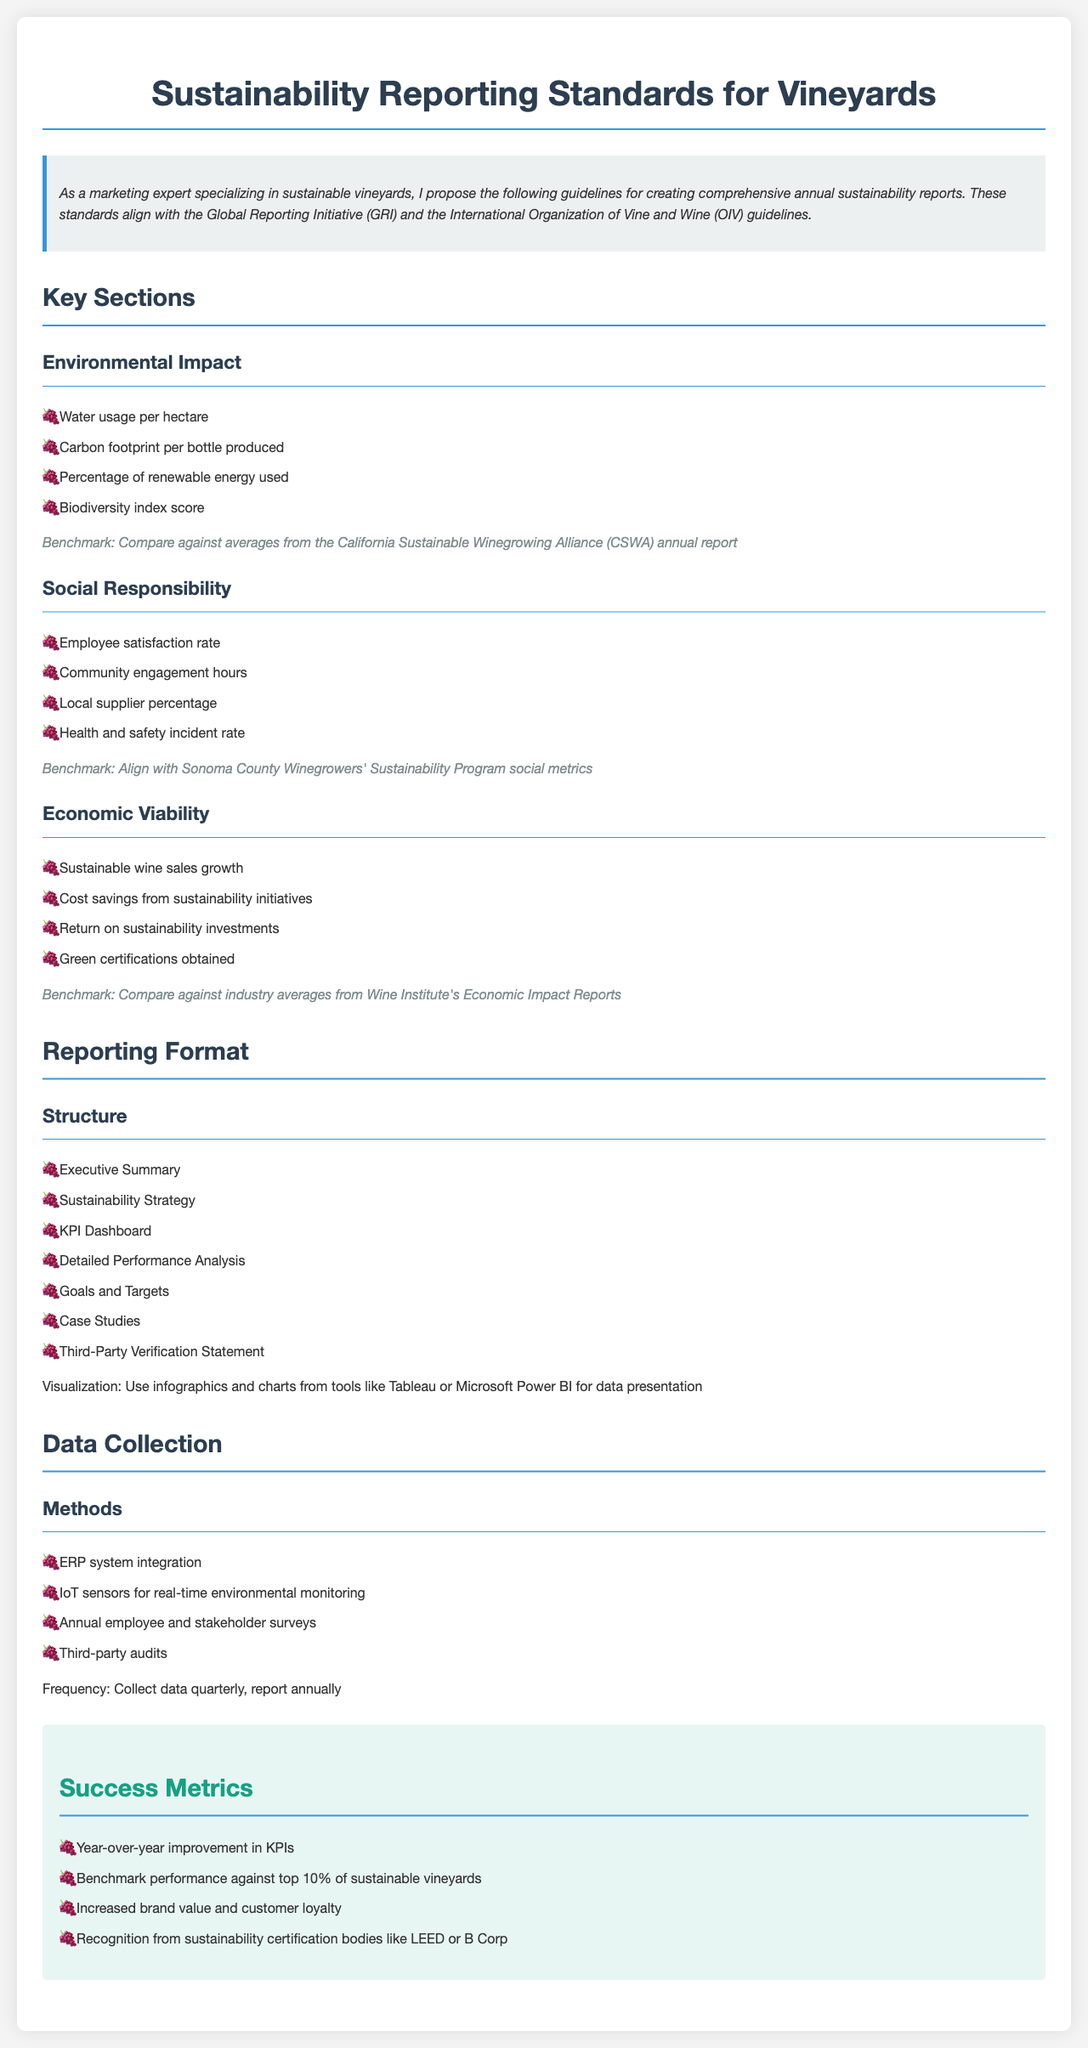What are the key sections in the report? The key sections include Environmental Impact, Social Responsibility, and Economic Viability.
Answer: Environmental Impact, Social Responsibility, Economic Viability What is a benchmark for Environmental Impact? The benchmark for Environmental Impact is to compare against averages from the California Sustainable Winegrowing Alliance annual report.
Answer: CSWA annual report What is the suggested frequency for data collection? The document states that data should be collected quarterly and reported annually.
Answer: Quarterly What success metric is related to brand value? The success metric regarding brand value refers to increased brand value and customer loyalty.
Answer: Increased brand value and customer loyalty What tool is mentioned for data visualization? The document mentions using Tableau or Microsoft Power BI for data visualization.
Answer: Tableau or Microsoft Power BI What metric measures employee engagement? Employee satisfaction rate is a metric that measures employee engagement in the document.
Answer: Employee satisfaction rate What is one method of data collection mentioned? One method of data collection mentioned is third-party audits.
Answer: Third-party audits How many key performance indicators are listed under Economic Viability? There are four key performance indicators listed under Economic Viability.
Answer: Four 